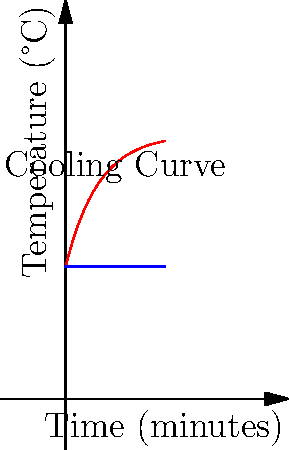As a video game developer optimizing a high-performance gaming PC for 4X genre games, you're tasked with analyzing the cooling system. The graph shows the CPU temperature curve during a cooldown period. If the initial CPU temperature is 80°C and the ambient temperature is 40°C, what is the approximate time constant τ of the cooling system in minutes? Assume the cooling follows Newton's Law of Cooling. To solve this problem, we'll use Newton's Law of Cooling and the concept of time constants in exponential decay. Let's break it down step-by-step:

1) Newton's Law of Cooling states that the rate of temperature change is proportional to the difference between the object's temperature and the ambient temperature. This leads to an exponential decay function:

   $T(t) = T_a + (T_0 - T_a) e^{-t/τ}$

   Where:
   $T(t)$ is the temperature at time $t$
   $T_a$ is the ambient temperature
   $T_0$ is the initial temperature
   $τ$ is the time constant

2) From the graph and question, we know:
   $T_a = 40°C$
   $T_0 = 80°C$

3) The time constant $τ$ is the time it takes for the temperature difference to decrease to $1/e$ (approximately 36.8%) of its initial value.

4) The initial temperature difference is:
   $T_0 - T_a = 80°C - 40°C = 40°C$

5) After one time constant, the temperature difference will be:
   $40°C * (1/e) ≈ 14.7°C$

6) So, we're looking for the time when the temperature reaches:
   $T(τ) = 40°C + 14.7°C = 54.7°C$

7) From the graph, we can estimate this occurs at around 10 minutes.

Therefore, the approximate time constant τ of the cooling system is 10 minutes.
Answer: 10 minutes 